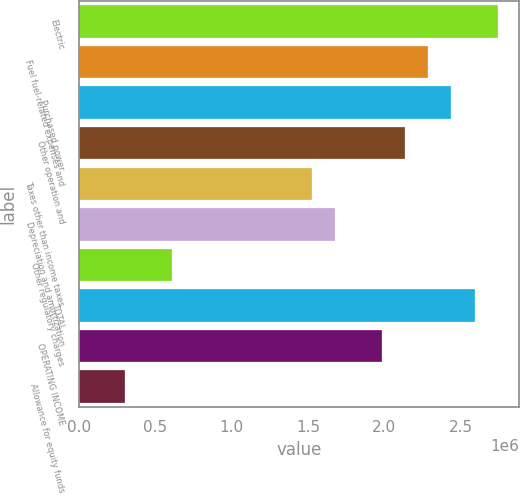Convert chart. <chart><loc_0><loc_0><loc_500><loc_500><bar_chart><fcel>Electric<fcel>Fuel fuel-related expenses and<fcel>Purchased power<fcel>Other operation and<fcel>Taxes other than income taxes<fcel>Depreciation and amortization<fcel>Other regulatory charges<fcel>TOTAL<fcel>OPERATING INCOME<fcel>Allowance for equity funds<nl><fcel>2.7427e+06<fcel>2.28576e+06<fcel>2.43808e+06<fcel>2.13345e+06<fcel>1.52419e+06<fcel>1.67651e+06<fcel>610310<fcel>2.59039e+06<fcel>1.98113e+06<fcel>305683<nl></chart> 